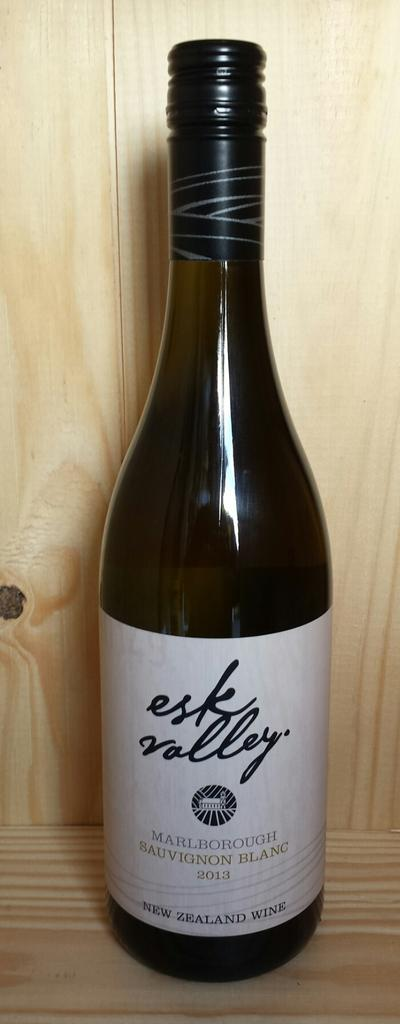What type of surface is visible in the image? There is a wooden surface in the image. What is placed on the wooden surface? There is a bottle with a cap on the wooden surface. What can be observed on the bottle? The bottle has a sticker on it. What information is provided on the sticker? There is text written on the sticker. What can be seen in the background of the image? There is a wooden wall in the background of the image. What is the aftermath of the stitch on the wooden surface in the image? There is no stitch present in the image, so there is no aftermath to discuss. 